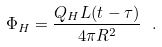Convert formula to latex. <formula><loc_0><loc_0><loc_500><loc_500>\Phi _ { H } = \frac { Q _ { H } L ( t - \tau ) } { 4 \pi R ^ { 2 } } \ .</formula> 